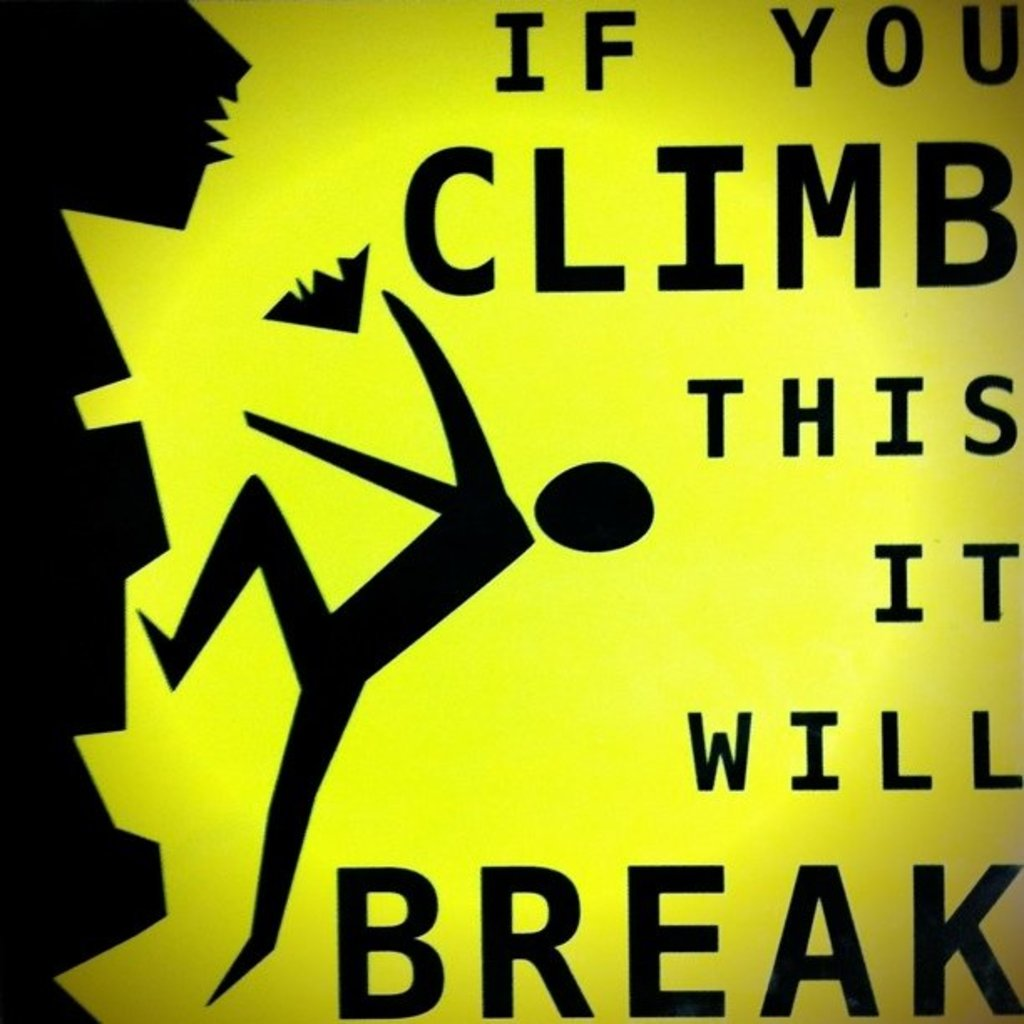What material might the structure in the image be made of that requires such a warning? The structure in question might be made from materials like plastic, thin metal, or composite materials that are not designed to bear much weight. These materials can easily bend, warp, or break under the pressure of a human climbing them, thereby justifying the need for a clear and direct warning as seen on the sign. 